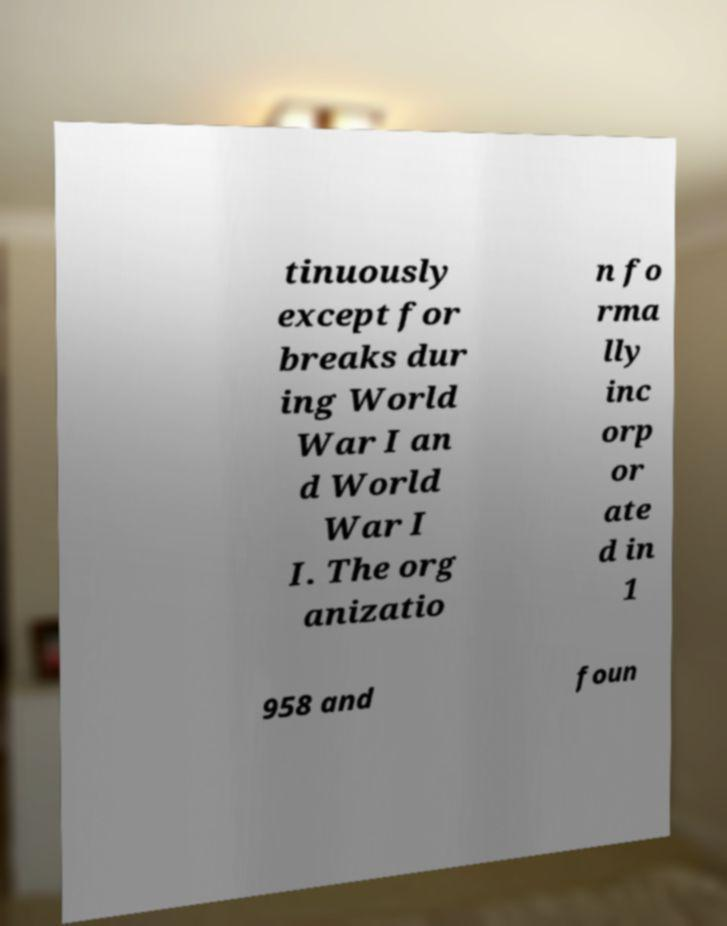Please identify and transcribe the text found in this image. tinuously except for breaks dur ing World War I an d World War I I. The org anizatio n fo rma lly inc orp or ate d in 1 958 and foun 